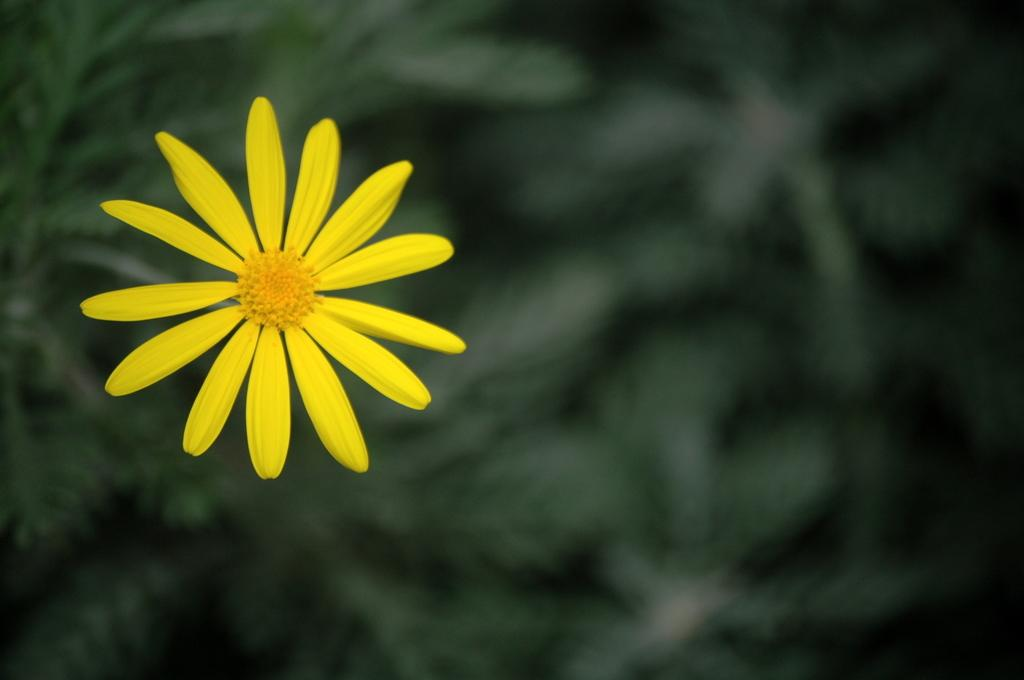What type of flower is in the image? There is a yellow color flower in the image. How would you describe the background of the image? The background of the image is blurred. What color is the background of the image? The background color is green. What news is the man in the image reading? There is no man present in the image, and therefore no news can be observed. 